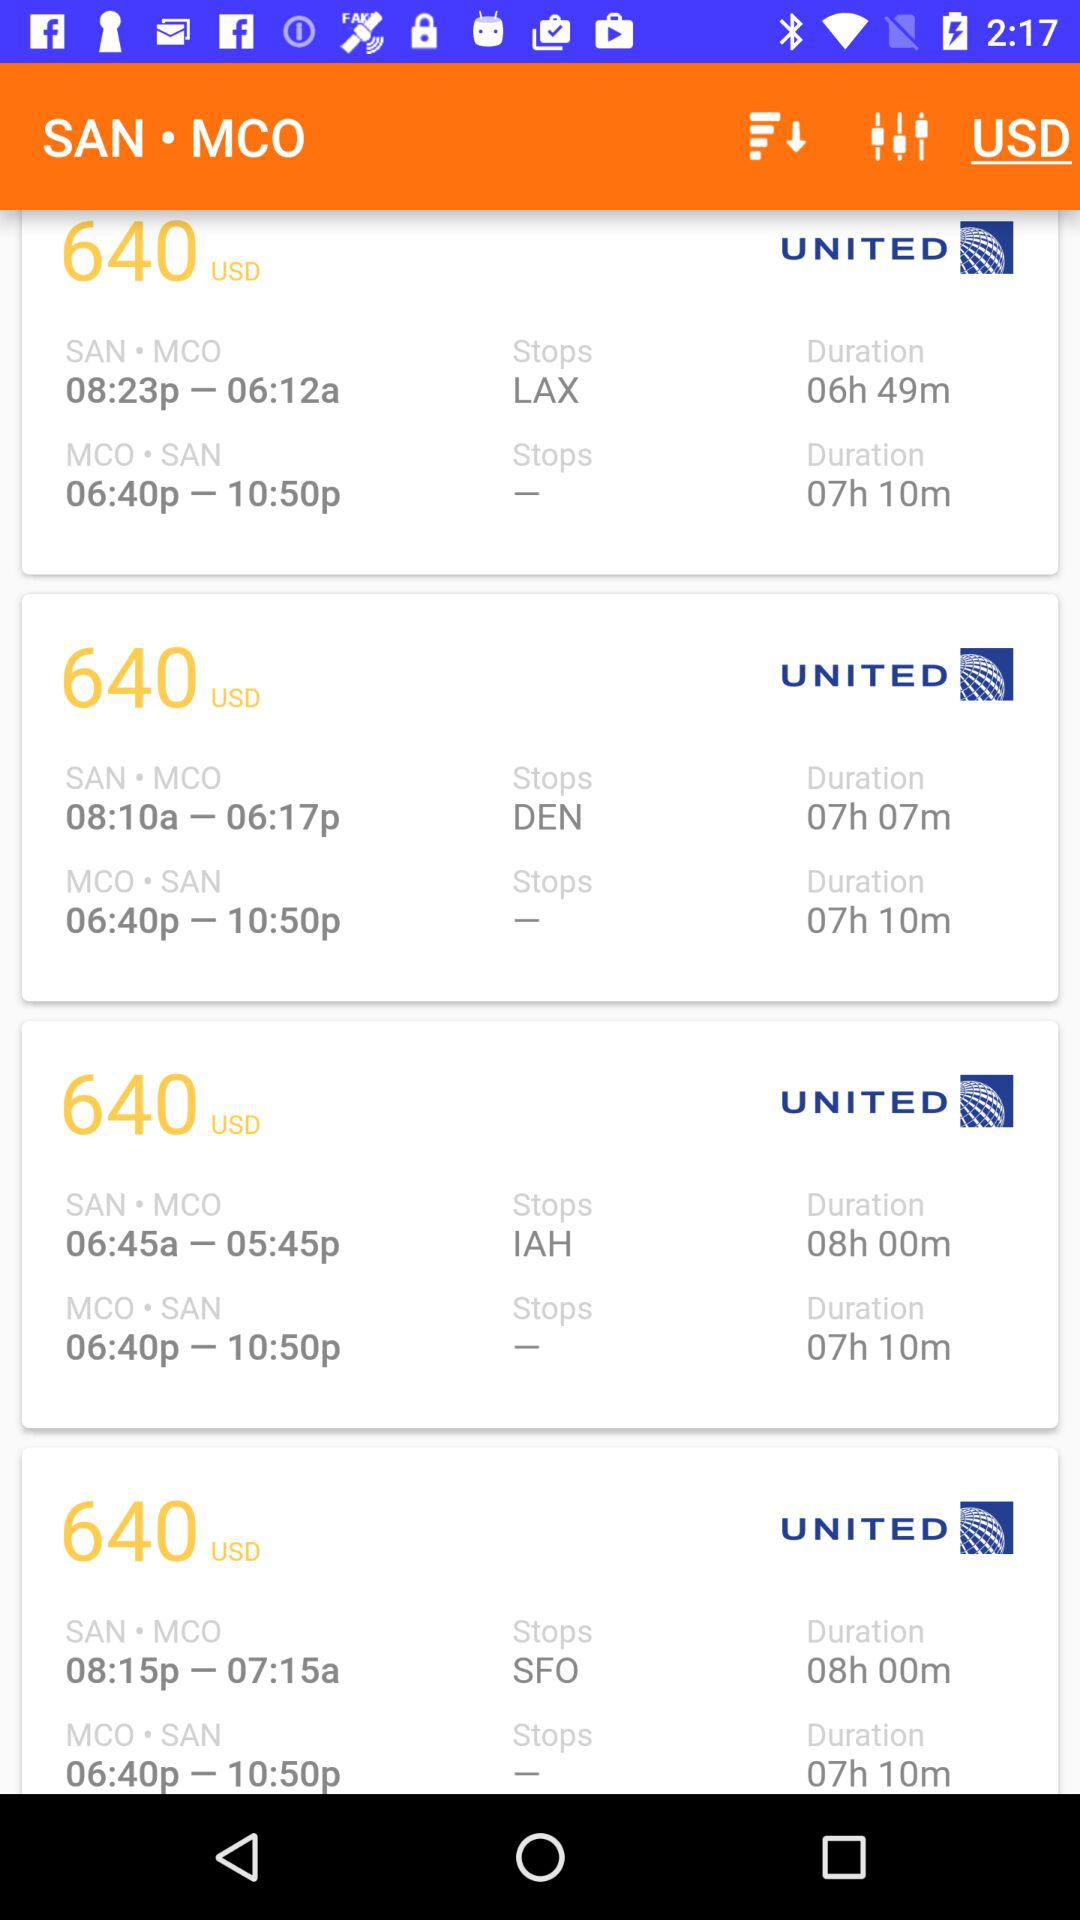What is the arrival airport? The arrival airport is MCO. 